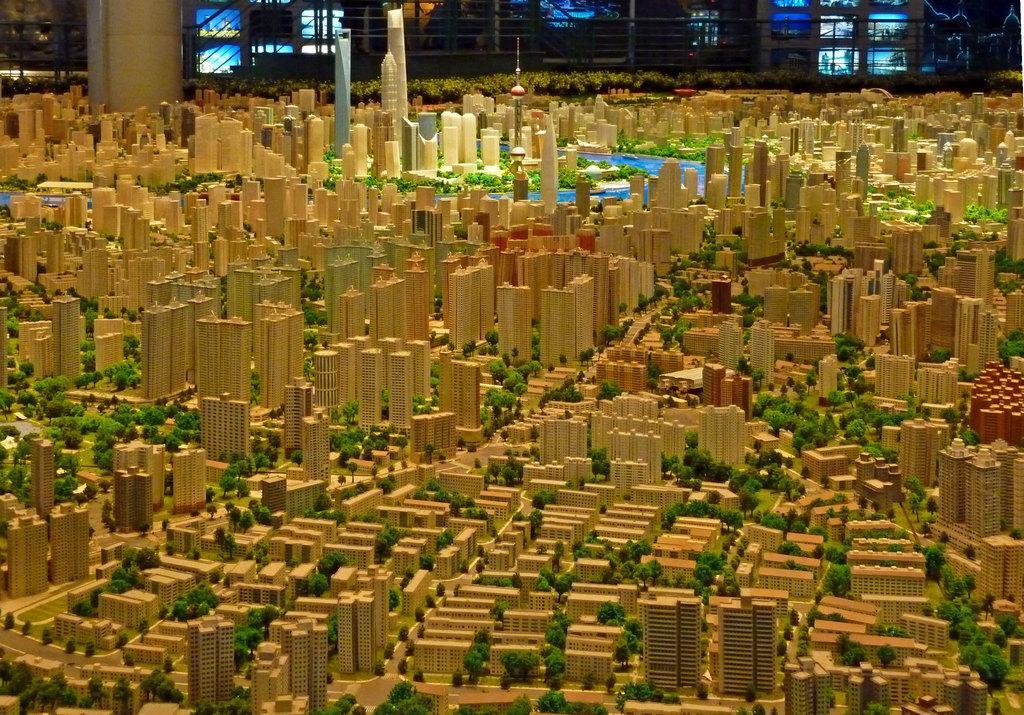Please provide a concise description of this image. In this image we can see the plan of buildings. In the background there is a pillar and we can see screens. 